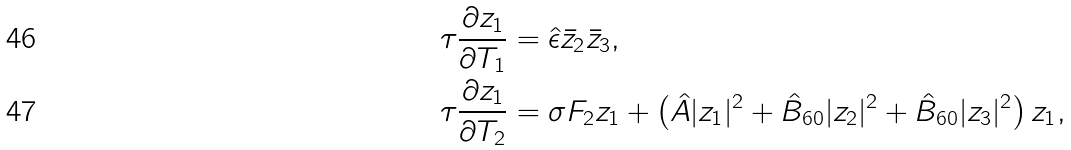Convert formula to latex. <formula><loc_0><loc_0><loc_500><loc_500>\tau \frac { \partial z _ { 1 } } { \partial T _ { 1 } } & = { \hat { \epsilon } } { \bar { z } } _ { 2 } { \bar { z } } _ { 3 } , \\ \tau \frac { \partial z _ { 1 } } { \partial T _ { 2 } } & = \sigma F _ { 2 } z _ { 1 } + \left ( { \hat { A } } | z _ { 1 } | ^ { 2 } + { \hat { B } } _ { 6 0 } | z _ { 2 } | ^ { 2 } + { \hat { B } } _ { 6 0 } | z _ { 3 } | ^ { 2 } \right ) z _ { 1 } ,</formula> 